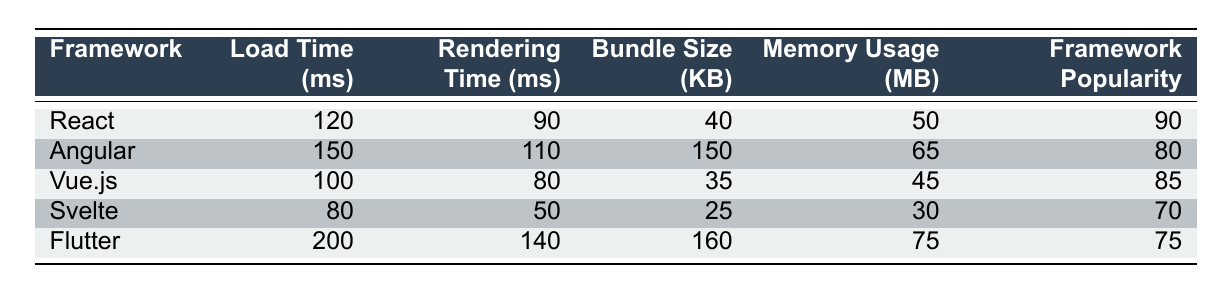What is the load time for Svelte? The table shows that Svelte has a load time of 80 milliseconds. This information can be found in the "Load Time (ms)" column corresponding to the "Svelte" row.
Answer: 80 ms Which framework has the smallest bundle size? By comparing the "Bundle Size (KB)" values in the table, Svelte has the smallest bundle size of 25 KB. This can be verified by looking through each row in that column.
Answer: 25 KB Is the rendering time for Vue.js less than that of Angular? The rendering time for Vue.js is 80 ms and for Angular, it is 110 ms. Since 80 is less than 110, the statement is true.
Answer: Yes What is the average memory usage of all the frameworks? First, sum the memory usage values: 50 + 65 + 45 + 30 + 75 = 265 MB. Then, divide by the number of frameworks (5) to find the average: 265/5 = 53 MB.
Answer: 53 MB Which framework has the highest framework popularity rating? The table indicates that React has the highest framework popularity at 90, which can be found in the "Framework Popularity" column.
Answer: React If you compare load times, how much faster is Vue.js than Flutter? Vue.js has a load time of 100 ms and Flutter has a load time of 200 ms. The difference is calculated as 200 - 100 = 100 ms. Thus, Vue.js is 100 ms faster than Flutter.
Answer: 100 ms True or False: Angular has a higher memory usage than React. Angular's memory usage is 65 MB, while React's is 50 MB; therefore, Angular does have a higher memory usage than React, making the statement true.
Answer: True Which frameworks have a rendering time greater than 100 ms? Looking at the "Rendering Time (ms)" column, only Angular (110 ms) and Flutter (140 ms) have rendering times greater than 100 ms. These frameworks can be identified by checking their respective values in that column.
Answer: Angular, Flutter What is the total bundle size of React and Vue.js combined? To find the total bundle size, add the bundle sizes of React (40 KB) and Vue.js (35 KB): 40 + 35 = 75 KB. This involves adding the values from the "Bundle Size (KB)" for both frameworks.
Answer: 75 KB 